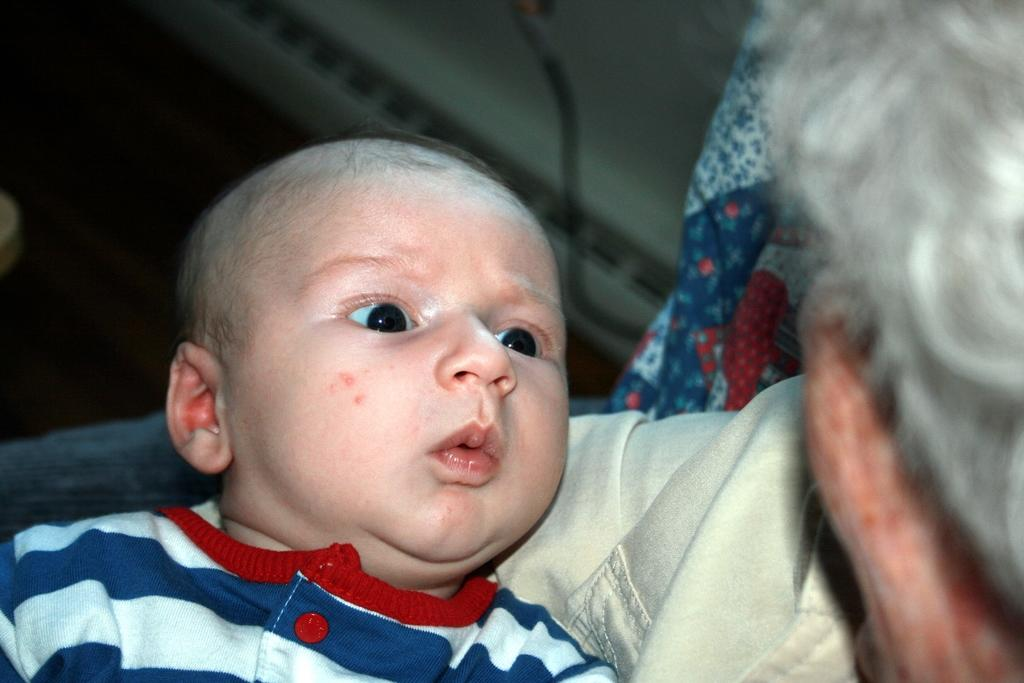Who or what is the main subject in the image? There is a person in the image. Can you describe the person's relationship with another individual in the image? There is a baby in the image, and the person may be a parent or caregiver. What type of material is present in the image? There is cloth in the image. What else can be seen in the image besides the people and cloth? There are some objects in the image. How would you describe the overall appearance of the image? The background of the image is dark. What type of weather can be seen in the image? There is no indication of weather in the image, as it is focused on the people and objects. 